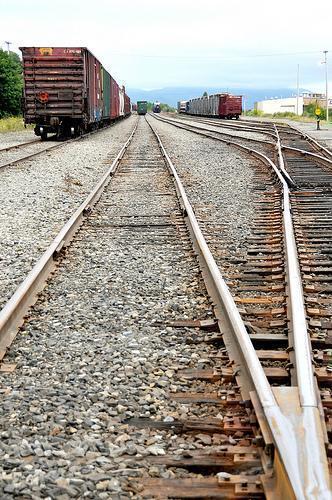How many trains are there?
Give a very brief answer. 4. 